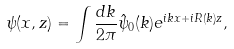Convert formula to latex. <formula><loc_0><loc_0><loc_500><loc_500>\psi ( x , z ) = \int \frac { d k } { 2 \pi } \hat { \psi } _ { 0 } ( k ) e ^ { i k x + i R ( k ) z } ,</formula> 